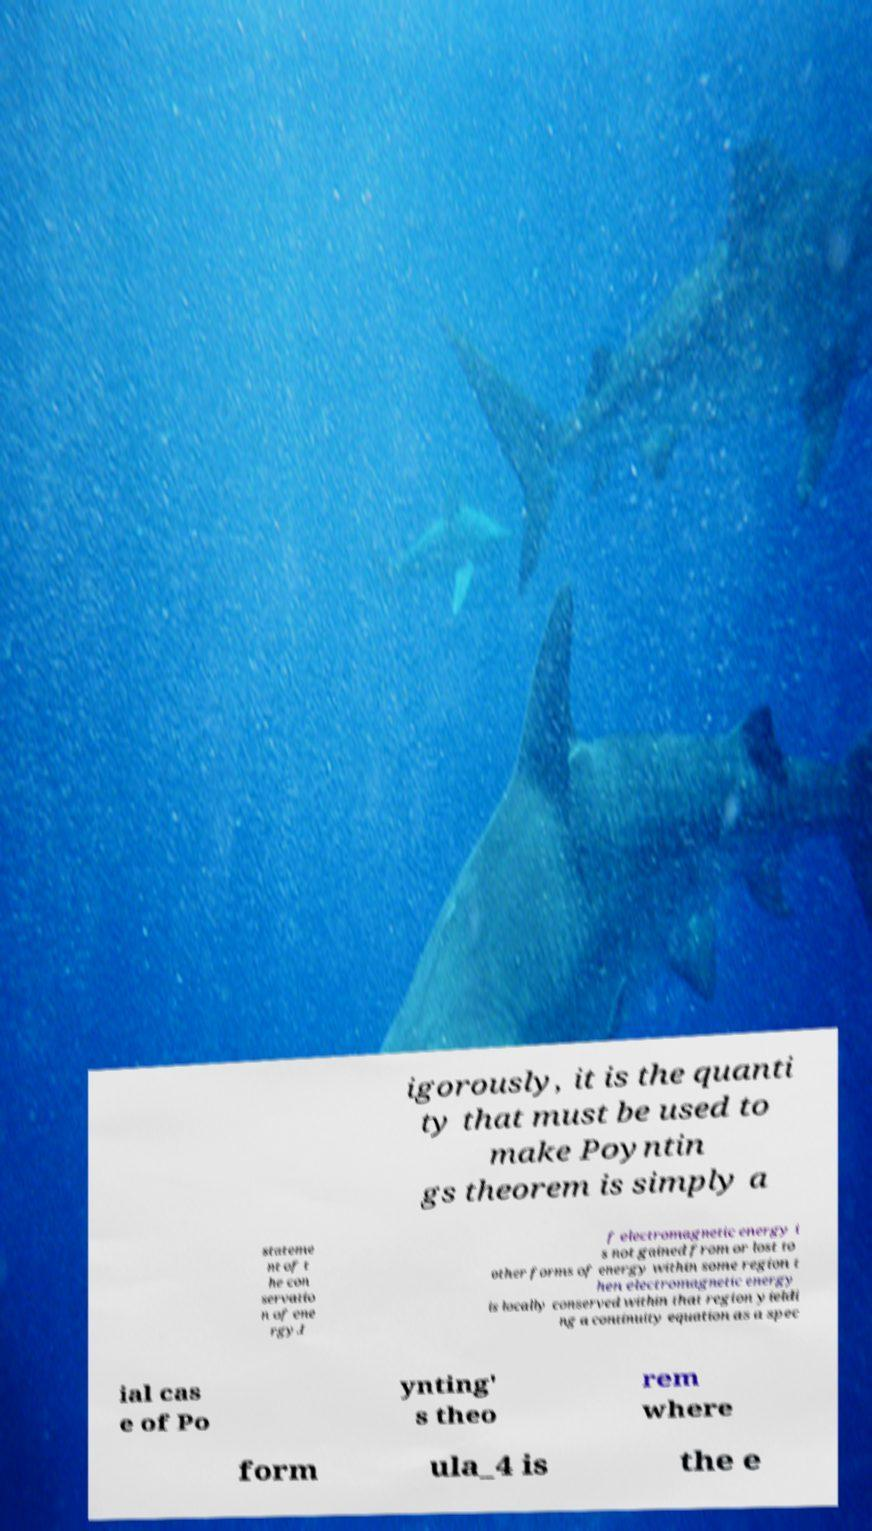Could you extract and type out the text from this image? igorously, it is the quanti ty that must be used to make Poyntin gs theorem is simply a stateme nt of t he con servatio n of ene rgy.I f electromagnetic energy i s not gained from or lost to other forms of energy within some region t hen electromagnetic energy is locally conserved within that region yieldi ng a continuity equation as a spec ial cas e of Po ynting' s theo rem where form ula_4 is the e 